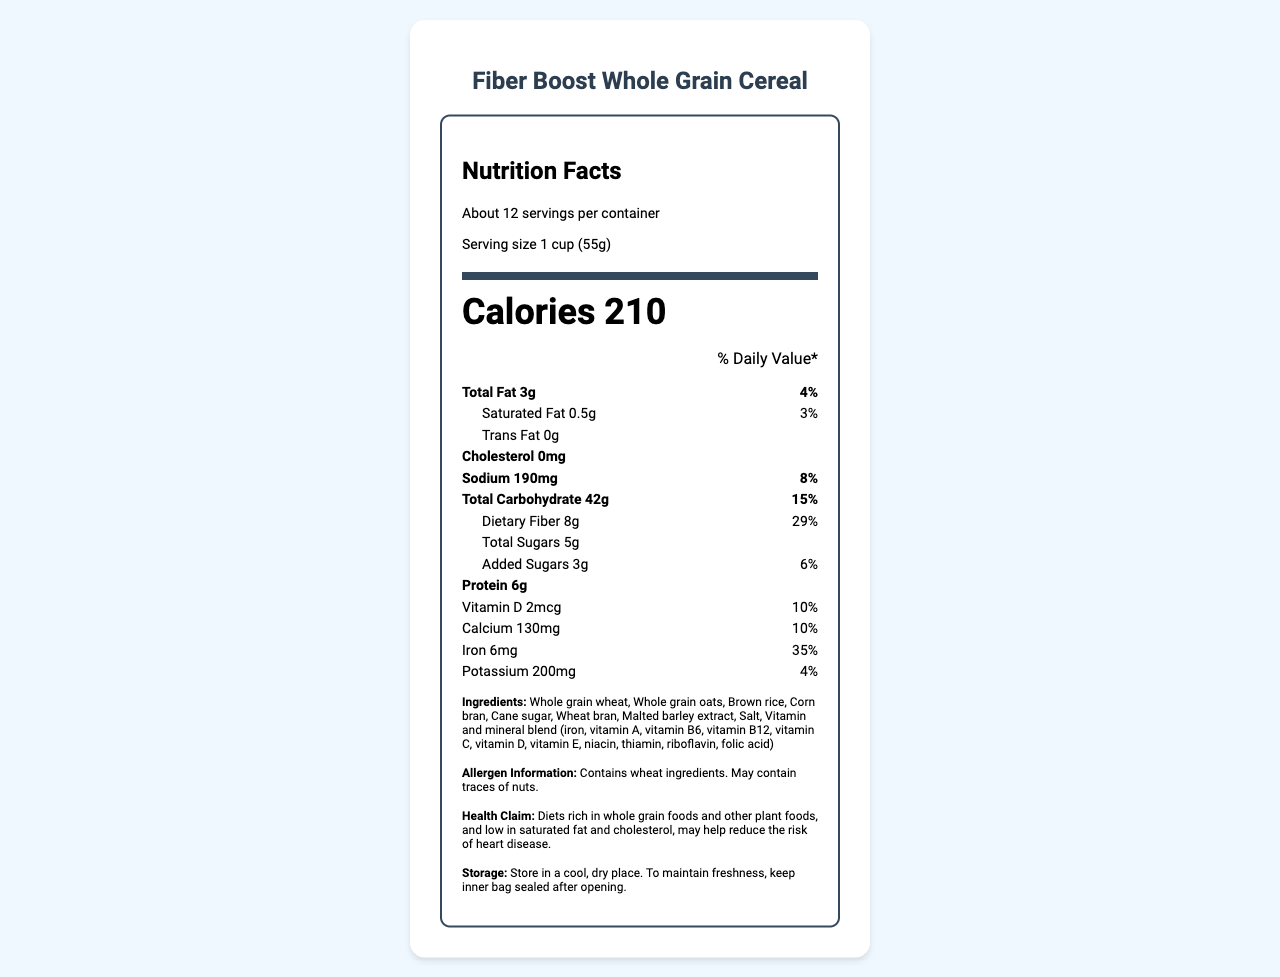what is the serving size? The serving size is listed near the top of the label and indicates how much of the cereal corresponds to the nutritional values provided.
Answer: 1 cup (55g) how many calories are in one serving? The number of calories per serving is displayed prominently on the label.
Answer: 210 what is the daily value percentage for dietary fiber? The daily value percentage for dietary fiber is listed under the Total Carbohydrate section of the nutrition label.
Answer: 29% how much protein is in one serving? The amount of protein per serving is stated in grams on the nutrition label.
Answer: 6g what are the ingredients? The ingredients are listed at the bottom of the nutrition label section.
Answer: Whole grain wheat, Whole grain oats, Brown rice, Corn bran, Cane sugar, Wheat bran, Malted barley extract, Salt, Vitamin and mineral blend (iron, vitamin A, vitamin B6, vitamin B12, vitamin C, vitamin D, vitamin E, niacin, thiamin, riboflavin, folic acid) what is the daily value percentage of iron in one serving? The daily value percentage for iron is displayed in the vitamins and minerals section of the nutrition label.
Answer: 35% which vitamin has the highest daily value percentage in one serving? A. Vitamin A B. Vitamin C C. Vitamin E D. Vitamin B6 The daily value percentages for the vitamins listed are: Vitamin A - 10%, Vitamin C - 15%, Vitamin E - 20%, Vitamin B6 - 25%. Hence, Vitamin E has the highest daily value percentage among the given options.
Answer: C. Vitamin E how much sodium is in one serving? A. 150mg B. 180mg C. 190mg D. 220mg The amount of sodium per serving is listed under the sodium section on the nutrition label as 190mg.
Answer: C. 190mg is the cereal gluten-free? The allergen information mentions that the cereal contains wheat ingredients, indicating it is not gluten-free.
Answer: No describe the main features of the Fiber Boost Whole Grain Cereal? This description covers the nutritional content (calories, fiber, vitamins, and minerals), main ingredients, storage instructions, and health benefits mentioned in the document.
Answer: The Fiber Boost Whole Grain Cereal provides 210 calories per serving, contains 8g of dietary fiber (29% daily value), and is fortified with various vitamins and minerals such as Vitamin D, Vitamin A, Vitamin C, and iron. It consists of whole grain wheat, oats, and other healthy ingredients. It is stored in a cool, dry place and the inner bag should be sealed after opening to maintain freshness. The cereal also carries a health claim that diets rich in whole grain foods may help reduce the risk of heart disease. how much-added sugar does one serving contain? The amount of added sugars is listed beneath the total sugars section of the nutrition label and specified as 3g.
Answer: 3g what is the expiration date of the cereal? The nutrition label provided does not contain any information regarding the expiration date of the cereal.
Answer: Not enough information 